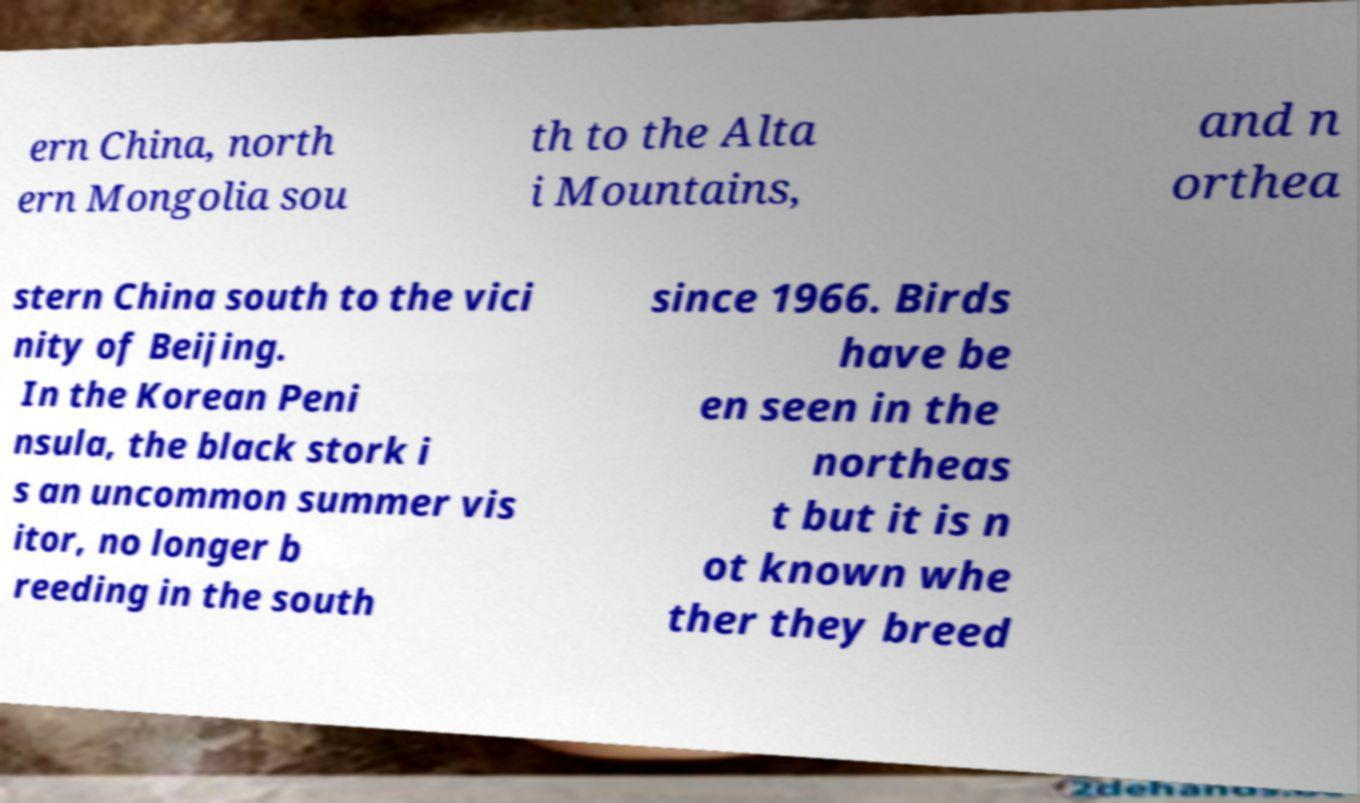Please read and relay the text visible in this image. What does it say? ern China, north ern Mongolia sou th to the Alta i Mountains, and n orthea stern China south to the vici nity of Beijing. In the Korean Peni nsula, the black stork i s an uncommon summer vis itor, no longer b reeding in the south since 1966. Birds have be en seen in the northeas t but it is n ot known whe ther they breed 